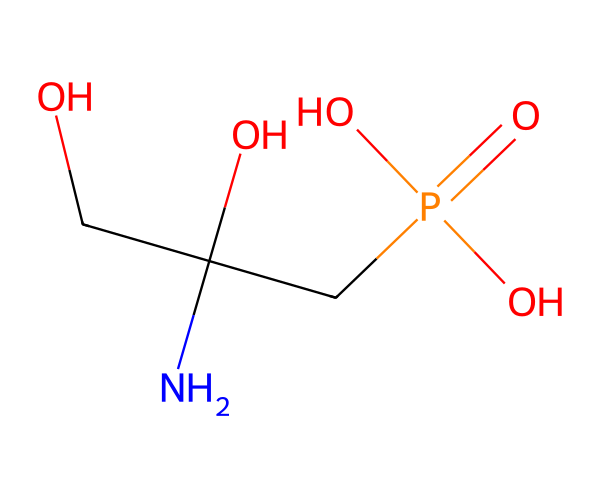what is the molecular formula of glyphosate? To derive the molecular formula from the SMILES representation, count the elements present: there are 3 carbon (C) atoms, 8 hydrogen (H) atoms, 1 nitrogen (N) atom, and 4 oxygen (O) atoms. This combines to form C3H8N1O4.
Answer: C3H8N1O4 how many oxygen atoms are present in glyphosate? By examining the SMILES notation, there are four instances of oxygen atoms indicated. Therefore, the total number of oxygen atoms in glyphosate is four.
Answer: 4 which functional group is present in glyphosate? Upon analyzing the structure, glyphosate contains a phosphonate functional group, which is indicated by the presence of a phosphorus atom bonded to oxygen atoms in a specific arrangement.
Answer: phosphonate what is the total number of bonds in glyphosate? The total number of bonds can be calculated by considering the connections in the molecular structure. In glyphosate, there are 8 single bonds connecting the atoms based on the SMILES representation.
Answer: 8 how many carbon atoms are there in glyphosate? From the SMILES structure, we can see that there are three carbon atoms present, indicated by the 'C' symbols in the representation.
Answer: 3 what type of herbicide is glyphosate classified as? Glyphosate is classified as a non-selective systemic herbicide because it kills a wide range of plants by inhibiting a specific pathway crucial for their growth.
Answer: non-selective systemic herbicide 